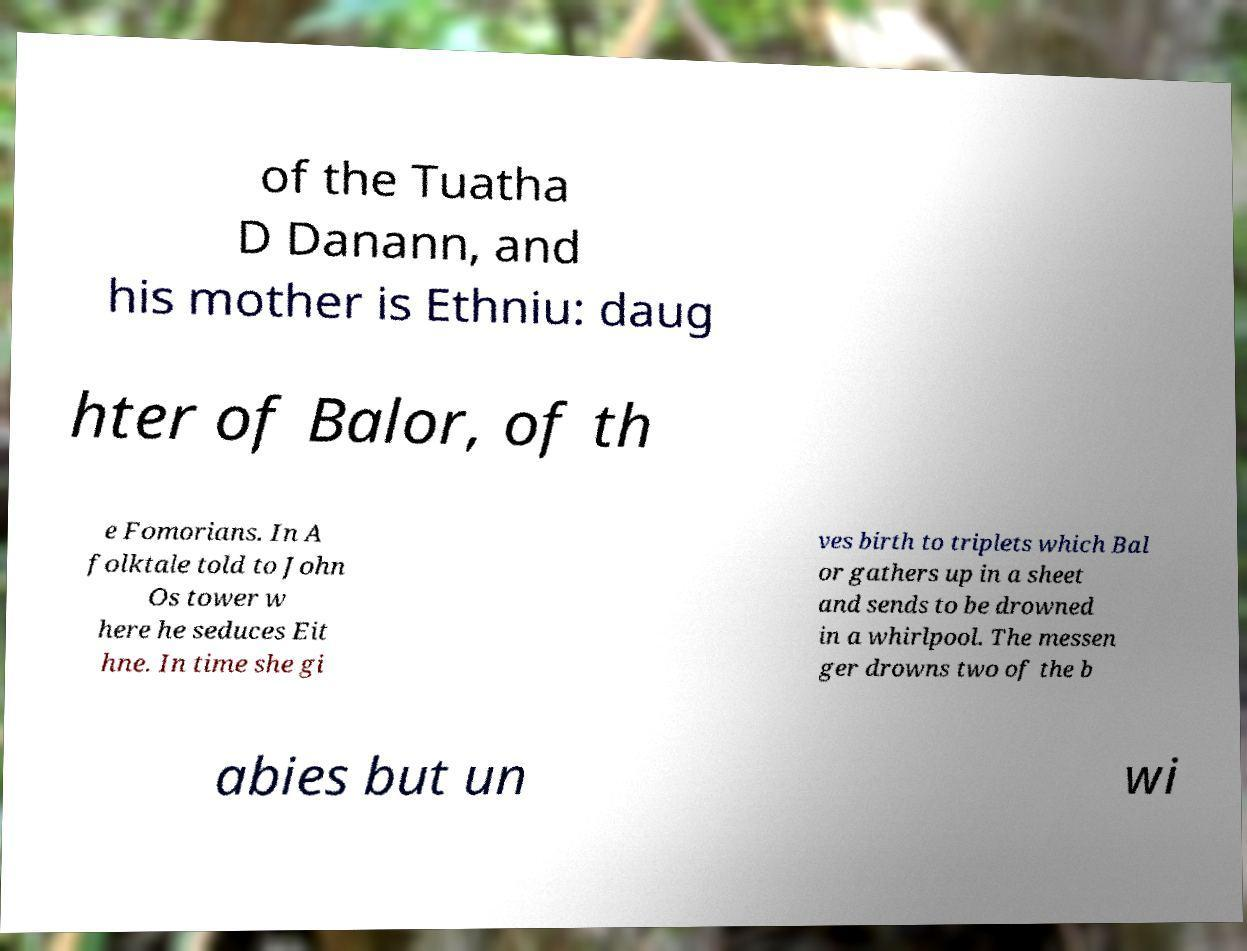Could you extract and type out the text from this image? of the Tuatha D Danann, and his mother is Ethniu: daug hter of Balor, of th e Fomorians. In A folktale told to John Os tower w here he seduces Eit hne. In time she gi ves birth to triplets which Bal or gathers up in a sheet and sends to be drowned in a whirlpool. The messen ger drowns two of the b abies but un wi 